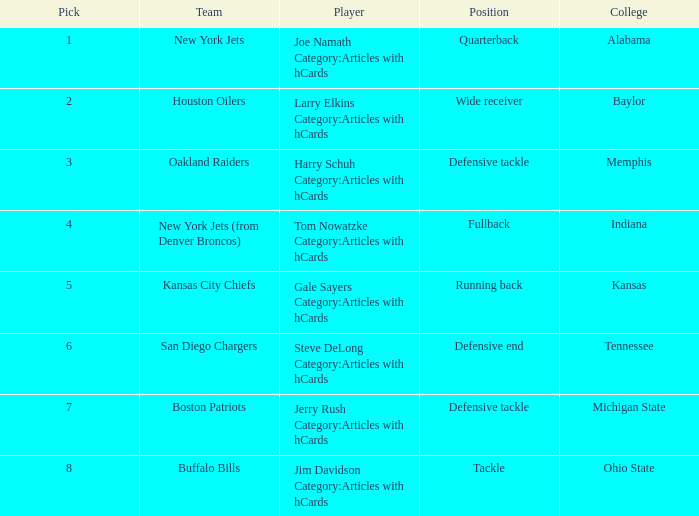What is the highest pick for the position of defensive end? 6.0. 